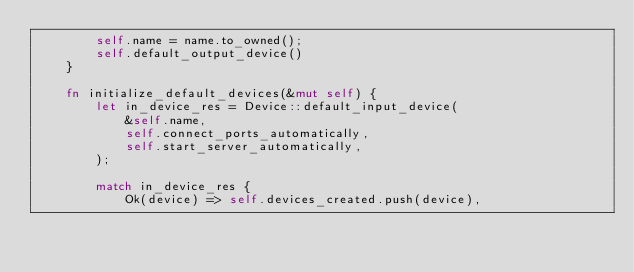<code> <loc_0><loc_0><loc_500><loc_500><_Rust_>        self.name = name.to_owned();
        self.default_output_device()
    }

    fn initialize_default_devices(&mut self) {
        let in_device_res = Device::default_input_device(
            &self.name,
            self.connect_ports_automatically,
            self.start_server_automatically,
        );

        match in_device_res {
            Ok(device) => self.devices_created.push(device),</code> 